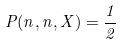Convert formula to latex. <formula><loc_0><loc_0><loc_500><loc_500>P ( n , n , X ) = \frac { 1 } { 2 }</formula> 